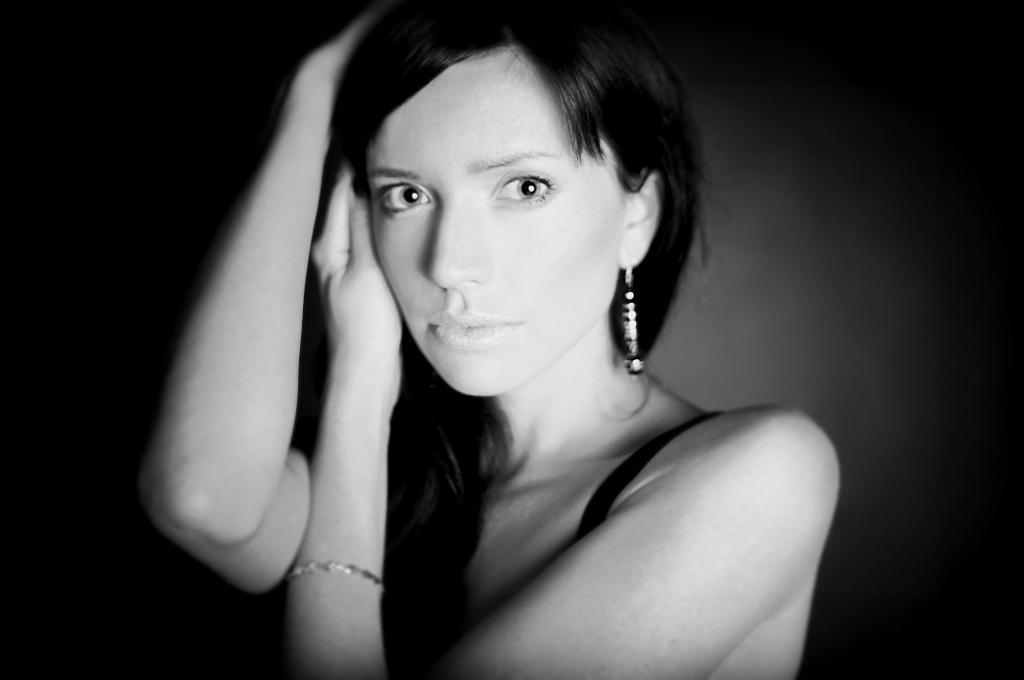How would you summarize this image in a sentence or two? Here in this picture we can see a woman present and this picture is a black and white image. 